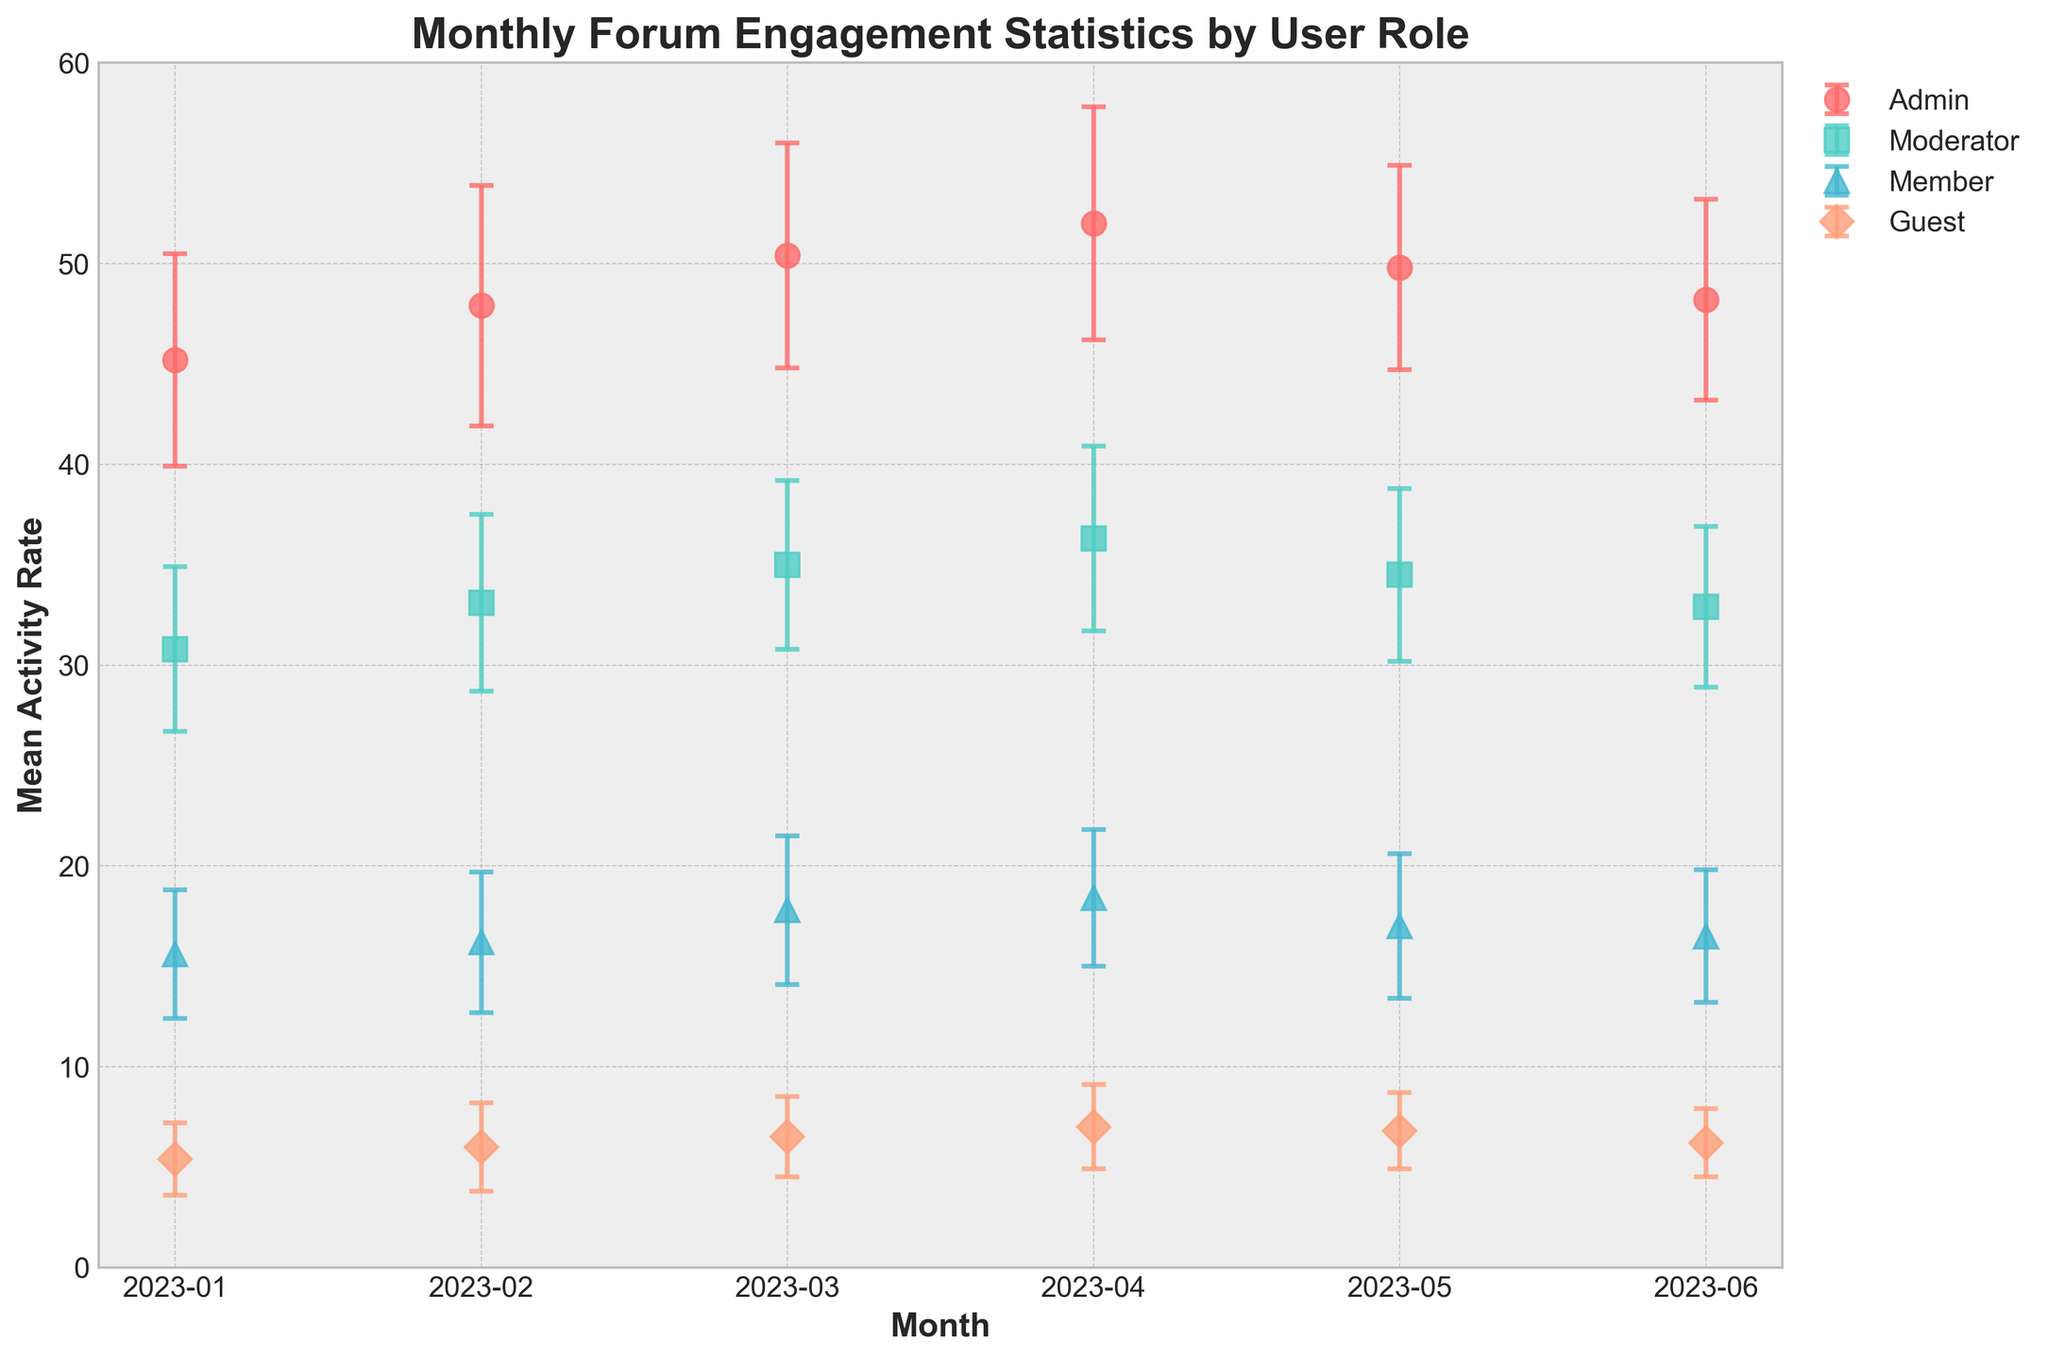Which user role had the highest mean activity rate in January 2023? The plot shows error bars with data points for different user roles. Look at the data point for January 2023 and find the role with the highest point.
Answer: Admin What is the range of the mean activity rate for Moderators over the months shown in the plot? Identify the highest and lowest mean activity rates for Moderators from the plotted data points. The highest value is 36.3 and the lowest is 30.8.
Answer: 30.8 to 36.3 Which month showed the highest activity rate for Guests, and what was the rate? Observe the data points corresponding to Guests for each month. The highest data point for Guests is in April 2023 at 7.0.
Answer: April 2023, 7.0 How does the mean activity rate for Members in March 2023 compare to that in May 2023? Compare the activity rates for Members in March and May. In March, it is 17.8, and in May, it is 17.0. So, March is higher.
Answer: Higher in March What can be inferred about the variability of activity rates for Admins between January and June 2023? Check the error bars (standard deviations) for Admins from January to June. The length of the error bars indicates variability, which seems fairly consistent but decreases slightly towards June.
Answer: Consistent with a slight decrease How does the error bar length of Guests in June 2023 compare to that of Members in the same month? Look at the lengths of the error bars for Guests and Members in June 2023. The Guests' error bar is shorter.
Answer: Shorter for Guests Is there a month when the activity rate for Moderators and Members were nearly equal? Visually inspect the plot for months where the data points for Moderators and Members are close to each other. In June, they are closer than in other months (32.9 vs. 16.5).
Answer: June 2023 What trend is observed in the activity rate of Admins from February to April 2023? Follow the data points for Admins from February to April. The rates increase from 47.9 to 52.0.
Answer: Increasing trend How does the average mean activity rate for Admins across all reported months compare to the average rate for Moderators? Calculate the average mean activity rate for Admins and Moderators: 
Admins: (45.2 + 47.9 + 50.4 + 52.0 + 49.8 + 48.2) / 6 ≈ 48.9
Moderators: (30.8 + 33.1 + 35.0 + 36.3 + 34.5 + 32.9) / 6 ≈ 33.8
Admins have a higher average rate.
Answer: Admins have a higher average rate What is the highest standard deviation observed for any user role in any month? Observe all the error bars and find the one with the maximum length. The highest standard deviation is for Admins in February 2023 (6.0).
Answer: 6.0 